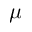Convert formula to latex. <formula><loc_0><loc_0><loc_500><loc_500>\mu</formula> 